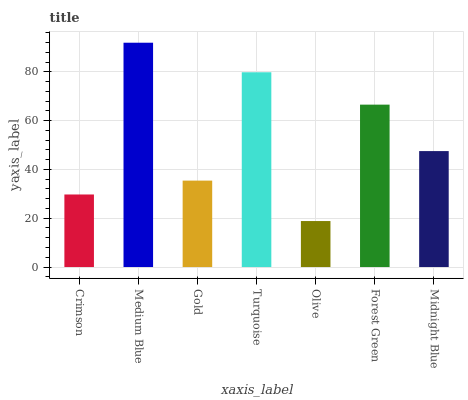Is Olive the minimum?
Answer yes or no. Yes. Is Medium Blue the maximum?
Answer yes or no. Yes. Is Gold the minimum?
Answer yes or no. No. Is Gold the maximum?
Answer yes or no. No. Is Medium Blue greater than Gold?
Answer yes or no. Yes. Is Gold less than Medium Blue?
Answer yes or no. Yes. Is Gold greater than Medium Blue?
Answer yes or no. No. Is Medium Blue less than Gold?
Answer yes or no. No. Is Midnight Blue the high median?
Answer yes or no. Yes. Is Midnight Blue the low median?
Answer yes or no. Yes. Is Crimson the high median?
Answer yes or no. No. Is Gold the low median?
Answer yes or no. No. 